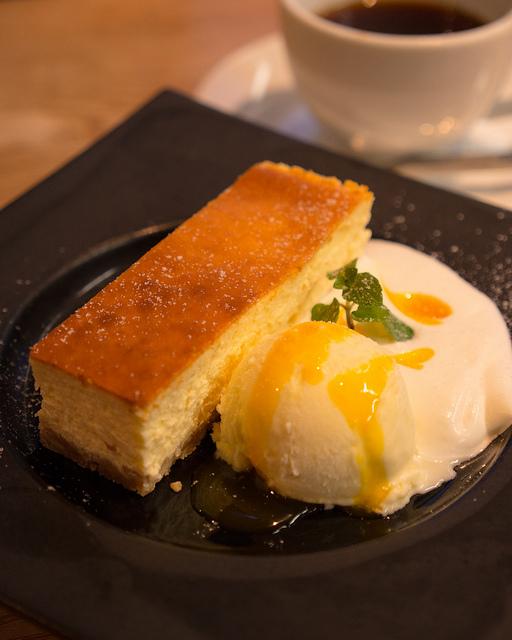What color is the plate?
Keep it brief. Black. IS this a formal meal?
Concise answer only. No. What is the color of the plate?
Give a very brief answer. Black. Is there cheesecake on the plate?
Keep it brief. Yes. Does the pic look sweet?
Be succinct. Yes. 